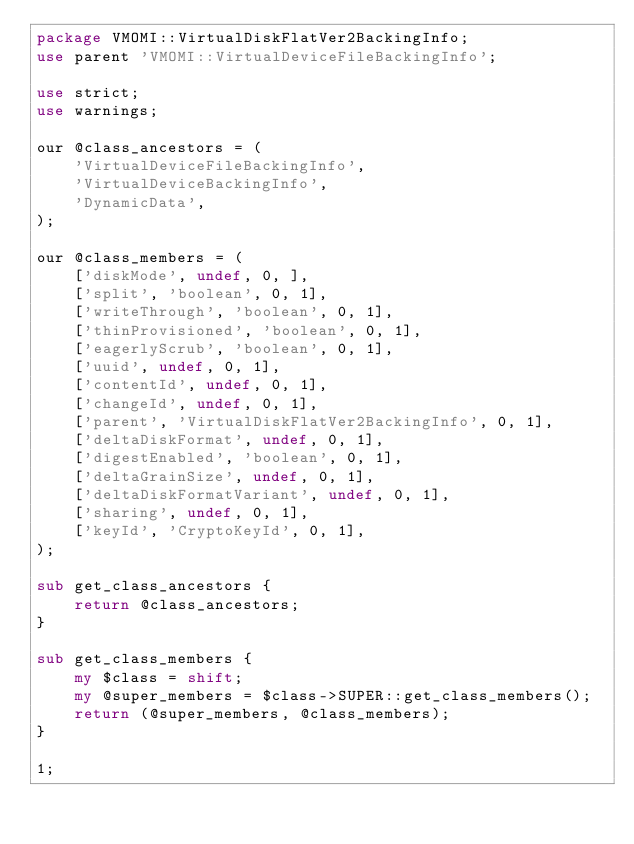Convert code to text. <code><loc_0><loc_0><loc_500><loc_500><_Perl_>package VMOMI::VirtualDiskFlatVer2BackingInfo;
use parent 'VMOMI::VirtualDeviceFileBackingInfo';

use strict;
use warnings;

our @class_ancestors = ( 
    'VirtualDeviceFileBackingInfo',
    'VirtualDeviceBackingInfo',
    'DynamicData',
);

our @class_members = ( 
    ['diskMode', undef, 0, ],
    ['split', 'boolean', 0, 1],
    ['writeThrough', 'boolean', 0, 1],
    ['thinProvisioned', 'boolean', 0, 1],
    ['eagerlyScrub', 'boolean', 0, 1],
    ['uuid', undef, 0, 1],
    ['contentId', undef, 0, 1],
    ['changeId', undef, 0, 1],
    ['parent', 'VirtualDiskFlatVer2BackingInfo', 0, 1],
    ['deltaDiskFormat', undef, 0, 1],
    ['digestEnabled', 'boolean', 0, 1],
    ['deltaGrainSize', undef, 0, 1],
    ['deltaDiskFormatVariant', undef, 0, 1],
    ['sharing', undef, 0, 1],
    ['keyId', 'CryptoKeyId', 0, 1],
);

sub get_class_ancestors {
    return @class_ancestors;
}

sub get_class_members {
    my $class = shift;
    my @super_members = $class->SUPER::get_class_members();
    return (@super_members, @class_members);
}

1;
</code> 